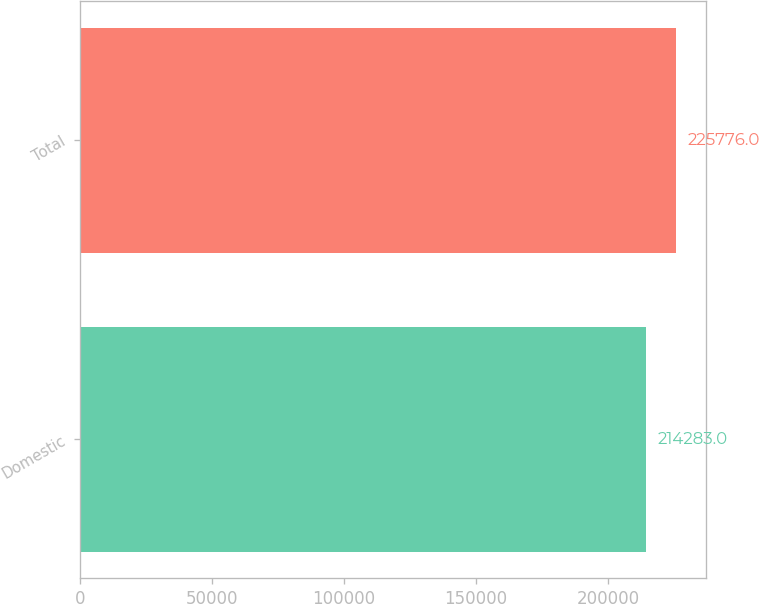Convert chart to OTSL. <chart><loc_0><loc_0><loc_500><loc_500><bar_chart><fcel>Domestic<fcel>Total<nl><fcel>214283<fcel>225776<nl></chart> 